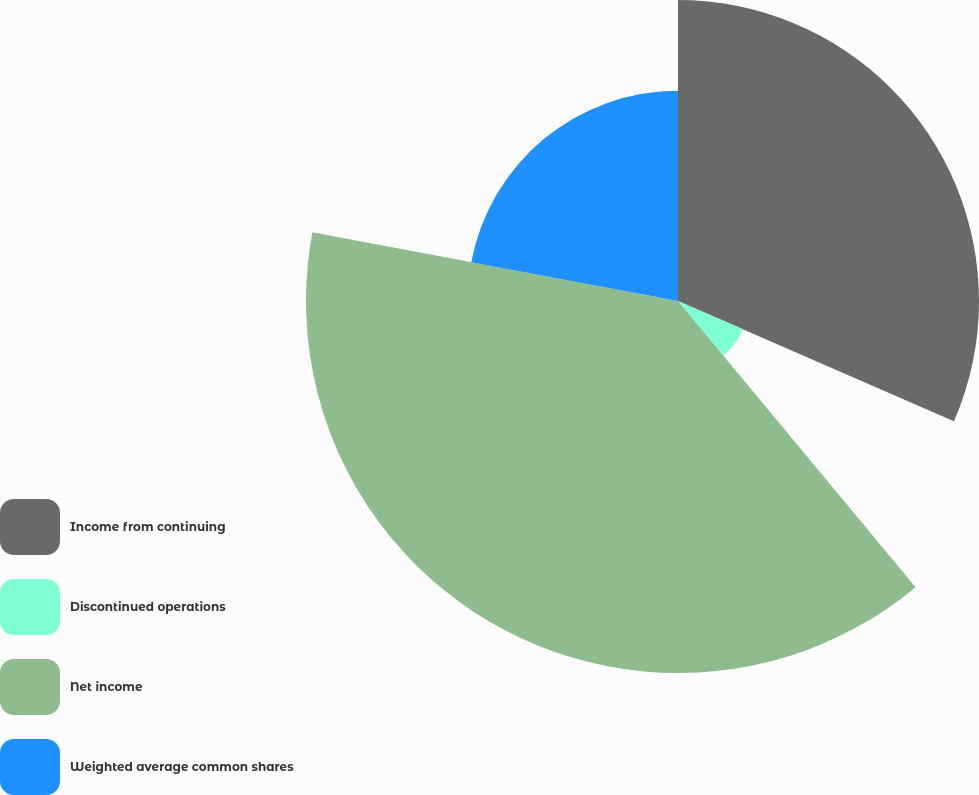Convert chart. <chart><loc_0><loc_0><loc_500><loc_500><pie_chart><fcel>Income from continuing<fcel>Discontinued operations<fcel>Net income<fcel>Weighted average common shares<nl><fcel>31.54%<fcel>7.43%<fcel>38.98%<fcel>22.04%<nl></chart> 